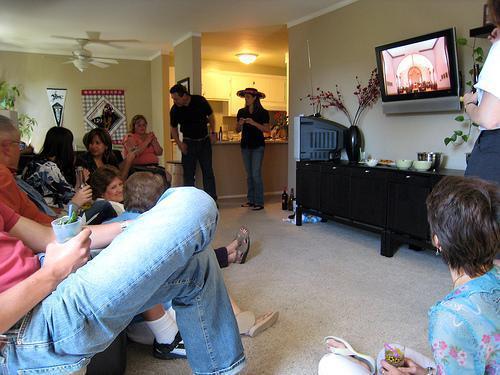How many fans are there in this photo?
Give a very brief answer. 1. 